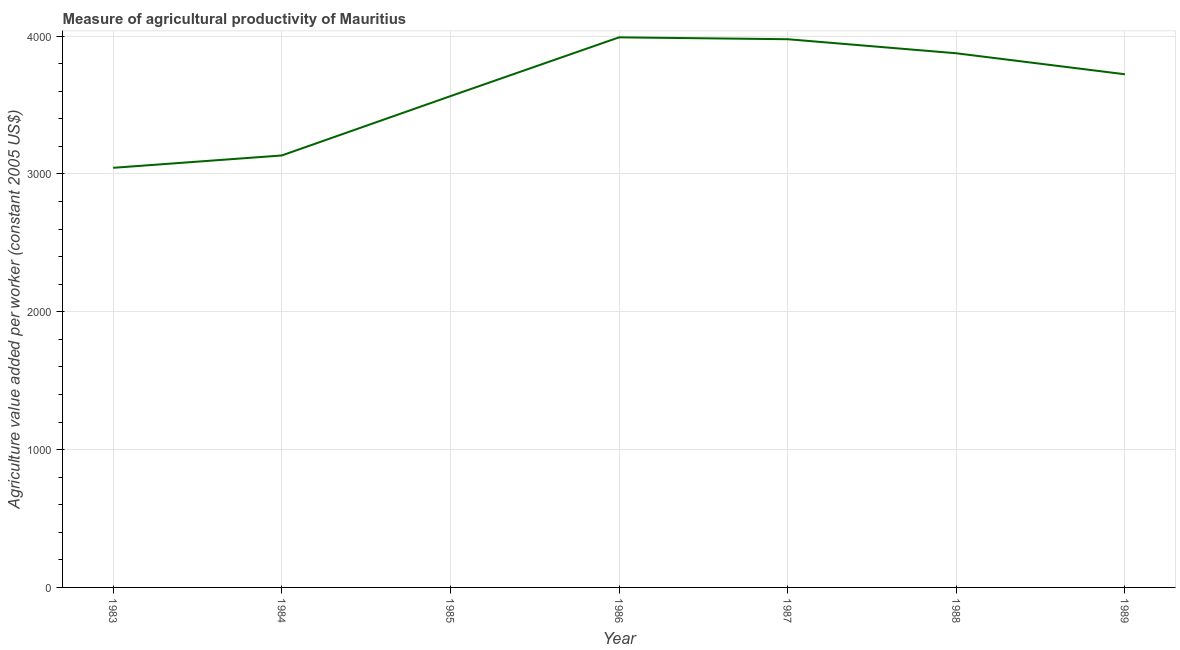What is the agriculture value added per worker in 1989?
Give a very brief answer. 3722.96. Across all years, what is the maximum agriculture value added per worker?
Keep it short and to the point. 3990.71. Across all years, what is the minimum agriculture value added per worker?
Your answer should be compact. 3044.25. In which year was the agriculture value added per worker maximum?
Keep it short and to the point. 1986. What is the sum of the agriculture value added per worker?
Your answer should be very brief. 2.53e+04. What is the difference between the agriculture value added per worker in 1988 and 1989?
Give a very brief answer. 152.24. What is the average agriculture value added per worker per year?
Offer a very short reply. 3615.45. What is the median agriculture value added per worker?
Your response must be concise. 3722.96. What is the ratio of the agriculture value added per worker in 1983 to that in 1984?
Your response must be concise. 0.97. What is the difference between the highest and the second highest agriculture value added per worker?
Provide a succinct answer. 13.6. Is the sum of the agriculture value added per worker in 1986 and 1987 greater than the maximum agriculture value added per worker across all years?
Offer a terse response. Yes. What is the difference between the highest and the lowest agriculture value added per worker?
Your answer should be compact. 946.46. Does the agriculture value added per worker monotonically increase over the years?
Ensure brevity in your answer.  No. How many lines are there?
Keep it short and to the point. 1. How many years are there in the graph?
Your response must be concise. 7. Are the values on the major ticks of Y-axis written in scientific E-notation?
Your answer should be compact. No. Does the graph contain any zero values?
Make the answer very short. No. Does the graph contain grids?
Ensure brevity in your answer.  Yes. What is the title of the graph?
Offer a terse response. Measure of agricultural productivity of Mauritius. What is the label or title of the Y-axis?
Give a very brief answer. Agriculture value added per worker (constant 2005 US$). What is the Agriculture value added per worker (constant 2005 US$) of 1983?
Keep it short and to the point. 3044.25. What is the Agriculture value added per worker (constant 2005 US$) in 1984?
Ensure brevity in your answer.  3133.79. What is the Agriculture value added per worker (constant 2005 US$) in 1985?
Provide a short and direct response. 3564.15. What is the Agriculture value added per worker (constant 2005 US$) in 1986?
Your response must be concise. 3990.71. What is the Agriculture value added per worker (constant 2005 US$) of 1987?
Offer a terse response. 3977.11. What is the Agriculture value added per worker (constant 2005 US$) in 1988?
Give a very brief answer. 3875.2. What is the Agriculture value added per worker (constant 2005 US$) of 1989?
Ensure brevity in your answer.  3722.96. What is the difference between the Agriculture value added per worker (constant 2005 US$) in 1983 and 1984?
Offer a terse response. -89.55. What is the difference between the Agriculture value added per worker (constant 2005 US$) in 1983 and 1985?
Offer a terse response. -519.9. What is the difference between the Agriculture value added per worker (constant 2005 US$) in 1983 and 1986?
Keep it short and to the point. -946.46. What is the difference between the Agriculture value added per worker (constant 2005 US$) in 1983 and 1987?
Provide a succinct answer. -932.86. What is the difference between the Agriculture value added per worker (constant 2005 US$) in 1983 and 1988?
Offer a very short reply. -830.96. What is the difference between the Agriculture value added per worker (constant 2005 US$) in 1983 and 1989?
Offer a terse response. -678.71. What is the difference between the Agriculture value added per worker (constant 2005 US$) in 1984 and 1985?
Offer a very short reply. -430.35. What is the difference between the Agriculture value added per worker (constant 2005 US$) in 1984 and 1986?
Your answer should be very brief. -856.91. What is the difference between the Agriculture value added per worker (constant 2005 US$) in 1984 and 1987?
Your response must be concise. -843.31. What is the difference between the Agriculture value added per worker (constant 2005 US$) in 1984 and 1988?
Provide a succinct answer. -741.41. What is the difference between the Agriculture value added per worker (constant 2005 US$) in 1984 and 1989?
Keep it short and to the point. -589.17. What is the difference between the Agriculture value added per worker (constant 2005 US$) in 1985 and 1986?
Provide a short and direct response. -426.56. What is the difference between the Agriculture value added per worker (constant 2005 US$) in 1985 and 1987?
Ensure brevity in your answer.  -412.96. What is the difference between the Agriculture value added per worker (constant 2005 US$) in 1985 and 1988?
Make the answer very short. -311.05. What is the difference between the Agriculture value added per worker (constant 2005 US$) in 1985 and 1989?
Your response must be concise. -158.81. What is the difference between the Agriculture value added per worker (constant 2005 US$) in 1986 and 1987?
Your answer should be compact. 13.6. What is the difference between the Agriculture value added per worker (constant 2005 US$) in 1986 and 1988?
Give a very brief answer. 115.5. What is the difference between the Agriculture value added per worker (constant 2005 US$) in 1986 and 1989?
Make the answer very short. 267.74. What is the difference between the Agriculture value added per worker (constant 2005 US$) in 1987 and 1988?
Provide a succinct answer. 101.91. What is the difference between the Agriculture value added per worker (constant 2005 US$) in 1987 and 1989?
Provide a short and direct response. 254.15. What is the difference between the Agriculture value added per worker (constant 2005 US$) in 1988 and 1989?
Make the answer very short. 152.24. What is the ratio of the Agriculture value added per worker (constant 2005 US$) in 1983 to that in 1985?
Offer a very short reply. 0.85. What is the ratio of the Agriculture value added per worker (constant 2005 US$) in 1983 to that in 1986?
Offer a terse response. 0.76. What is the ratio of the Agriculture value added per worker (constant 2005 US$) in 1983 to that in 1987?
Offer a very short reply. 0.77. What is the ratio of the Agriculture value added per worker (constant 2005 US$) in 1983 to that in 1988?
Ensure brevity in your answer.  0.79. What is the ratio of the Agriculture value added per worker (constant 2005 US$) in 1983 to that in 1989?
Keep it short and to the point. 0.82. What is the ratio of the Agriculture value added per worker (constant 2005 US$) in 1984 to that in 1985?
Your answer should be very brief. 0.88. What is the ratio of the Agriculture value added per worker (constant 2005 US$) in 1984 to that in 1986?
Provide a succinct answer. 0.79. What is the ratio of the Agriculture value added per worker (constant 2005 US$) in 1984 to that in 1987?
Your answer should be very brief. 0.79. What is the ratio of the Agriculture value added per worker (constant 2005 US$) in 1984 to that in 1988?
Offer a very short reply. 0.81. What is the ratio of the Agriculture value added per worker (constant 2005 US$) in 1984 to that in 1989?
Ensure brevity in your answer.  0.84. What is the ratio of the Agriculture value added per worker (constant 2005 US$) in 1985 to that in 1986?
Your answer should be very brief. 0.89. What is the ratio of the Agriculture value added per worker (constant 2005 US$) in 1985 to that in 1987?
Provide a short and direct response. 0.9. What is the ratio of the Agriculture value added per worker (constant 2005 US$) in 1985 to that in 1988?
Give a very brief answer. 0.92. What is the ratio of the Agriculture value added per worker (constant 2005 US$) in 1985 to that in 1989?
Offer a terse response. 0.96. What is the ratio of the Agriculture value added per worker (constant 2005 US$) in 1986 to that in 1987?
Give a very brief answer. 1. What is the ratio of the Agriculture value added per worker (constant 2005 US$) in 1986 to that in 1989?
Provide a short and direct response. 1.07. What is the ratio of the Agriculture value added per worker (constant 2005 US$) in 1987 to that in 1989?
Give a very brief answer. 1.07. What is the ratio of the Agriculture value added per worker (constant 2005 US$) in 1988 to that in 1989?
Provide a succinct answer. 1.04. 